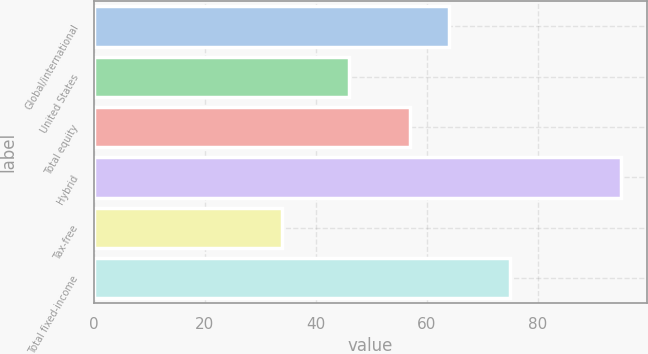Convert chart to OTSL. <chart><loc_0><loc_0><loc_500><loc_500><bar_chart><fcel>Global/international<fcel>United States<fcel>Total equity<fcel>Hybrid<fcel>Tax-free<fcel>Total fixed-income<nl><fcel>64<fcel>46<fcel>57<fcel>95<fcel>34<fcel>75<nl></chart> 